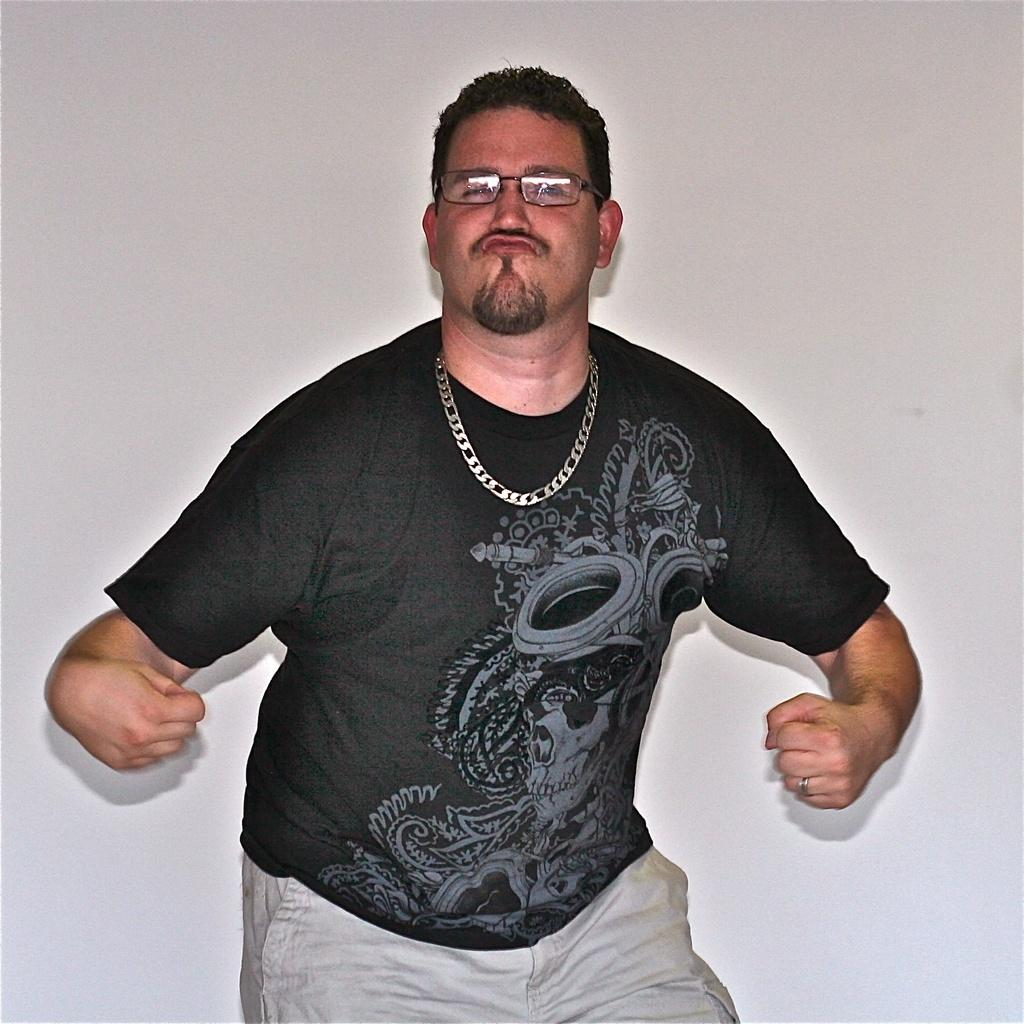Who is in the image? There is a man in the image. What is the man wearing on his upper body? The man is wearing a black T-shirt. What accessory is the man wearing on his face? The man is wearing spectacles. What type of jewelry is the man wearing? The man is wearing a chain. What is the man doing in the image? The man is posing for a photo. What can be seen behind the man in the image? There is a white wall in the background of the image. What type of notebook is the man holding in the image? There is no notebook present in the image; the man is not holding any object. 